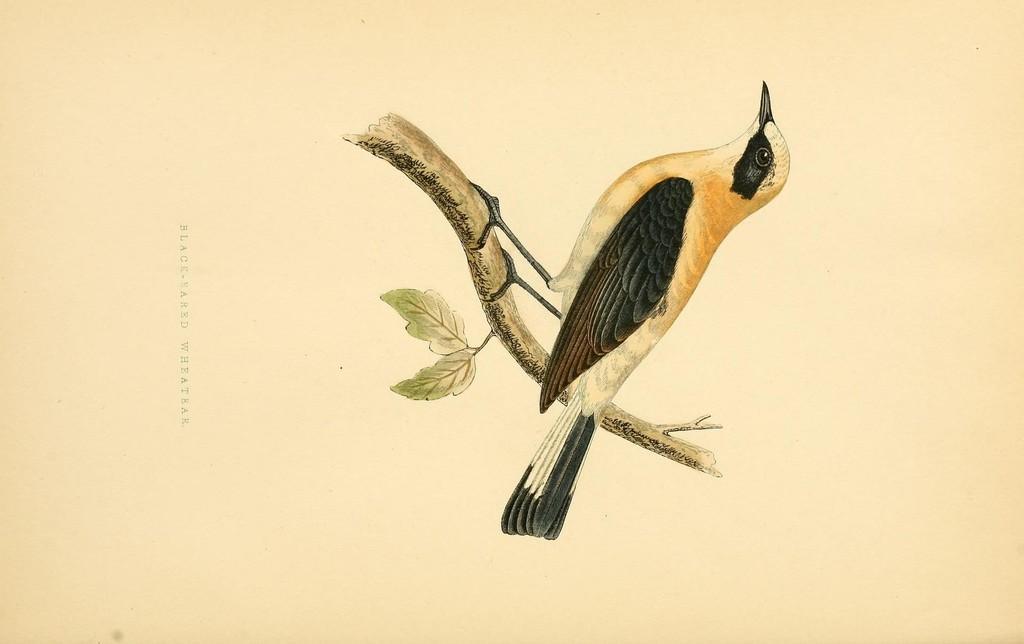Please provide a concise description of this image. In this image we can see a bird on the branch of tree and there are leaves. And we can see the text written on the poster. 